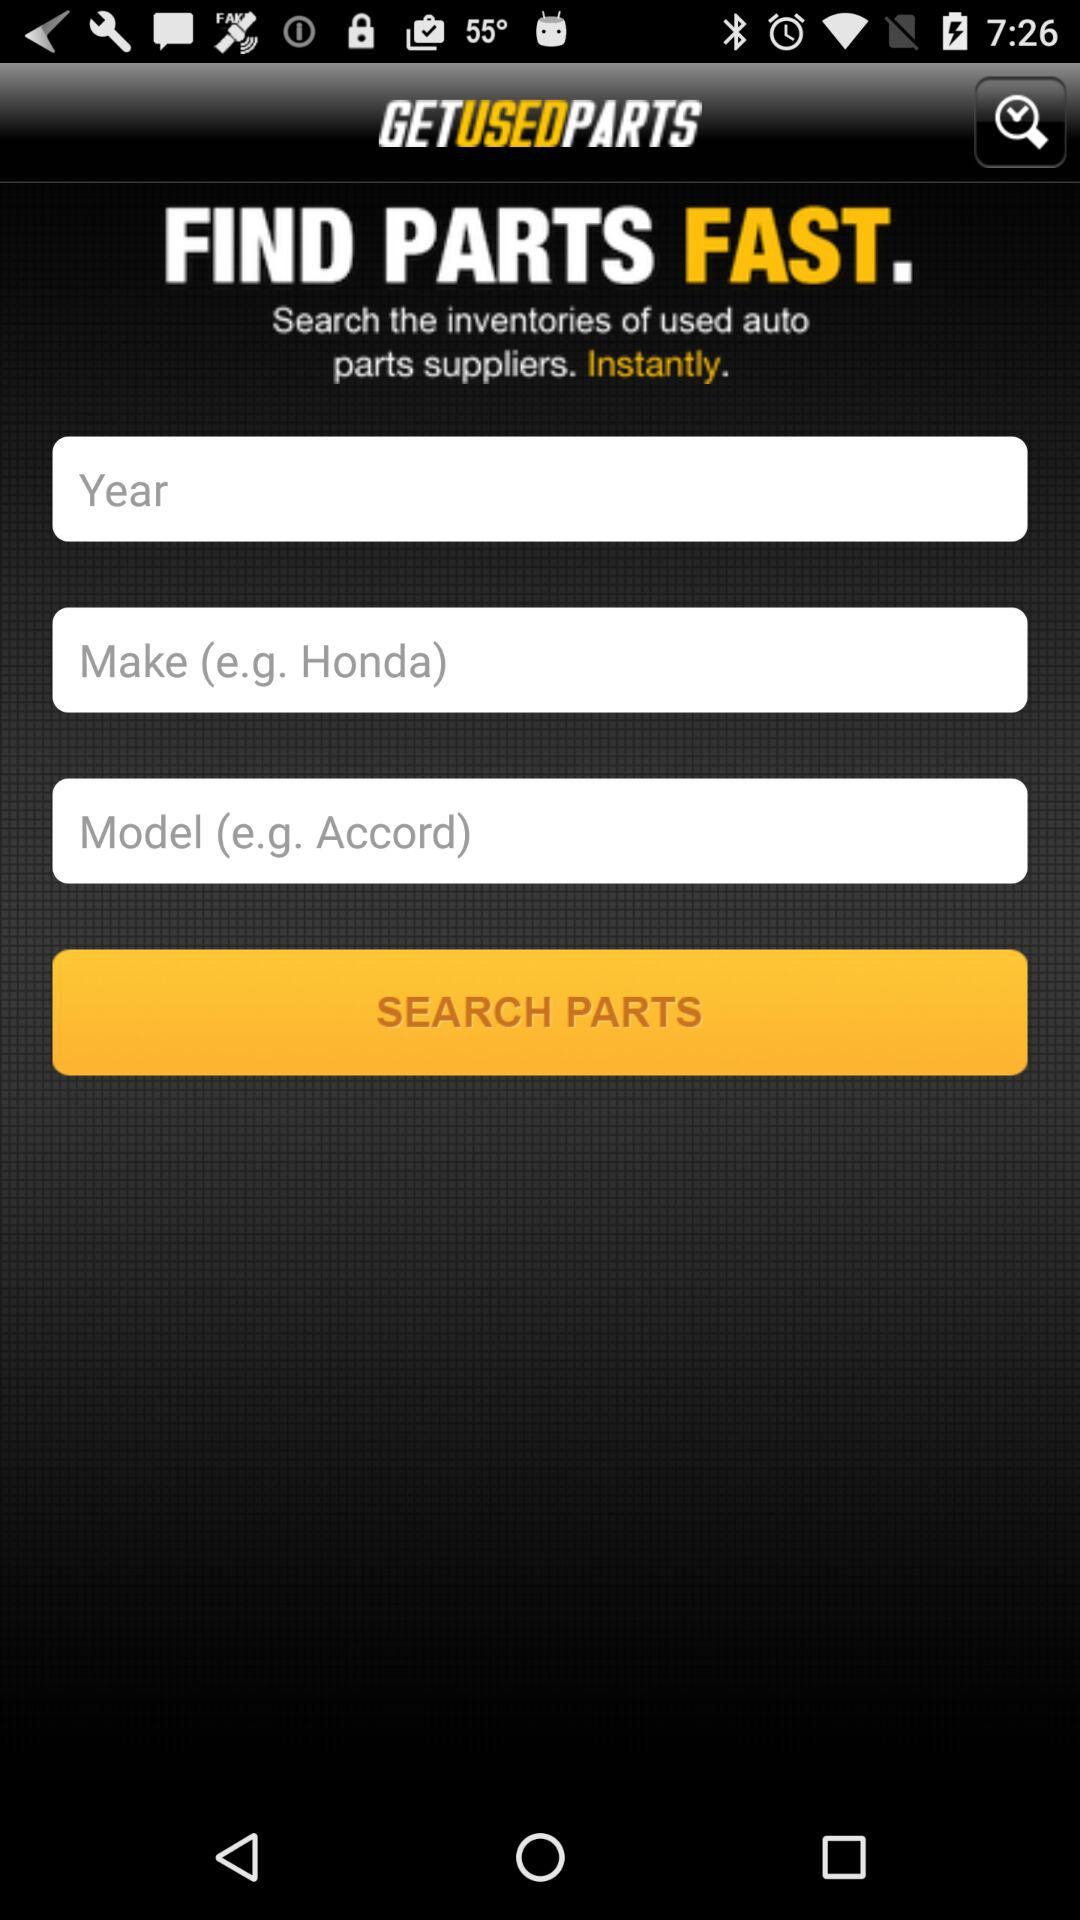How many text inputs are there for entering vehicle information?
Answer the question using a single word or phrase. 3 